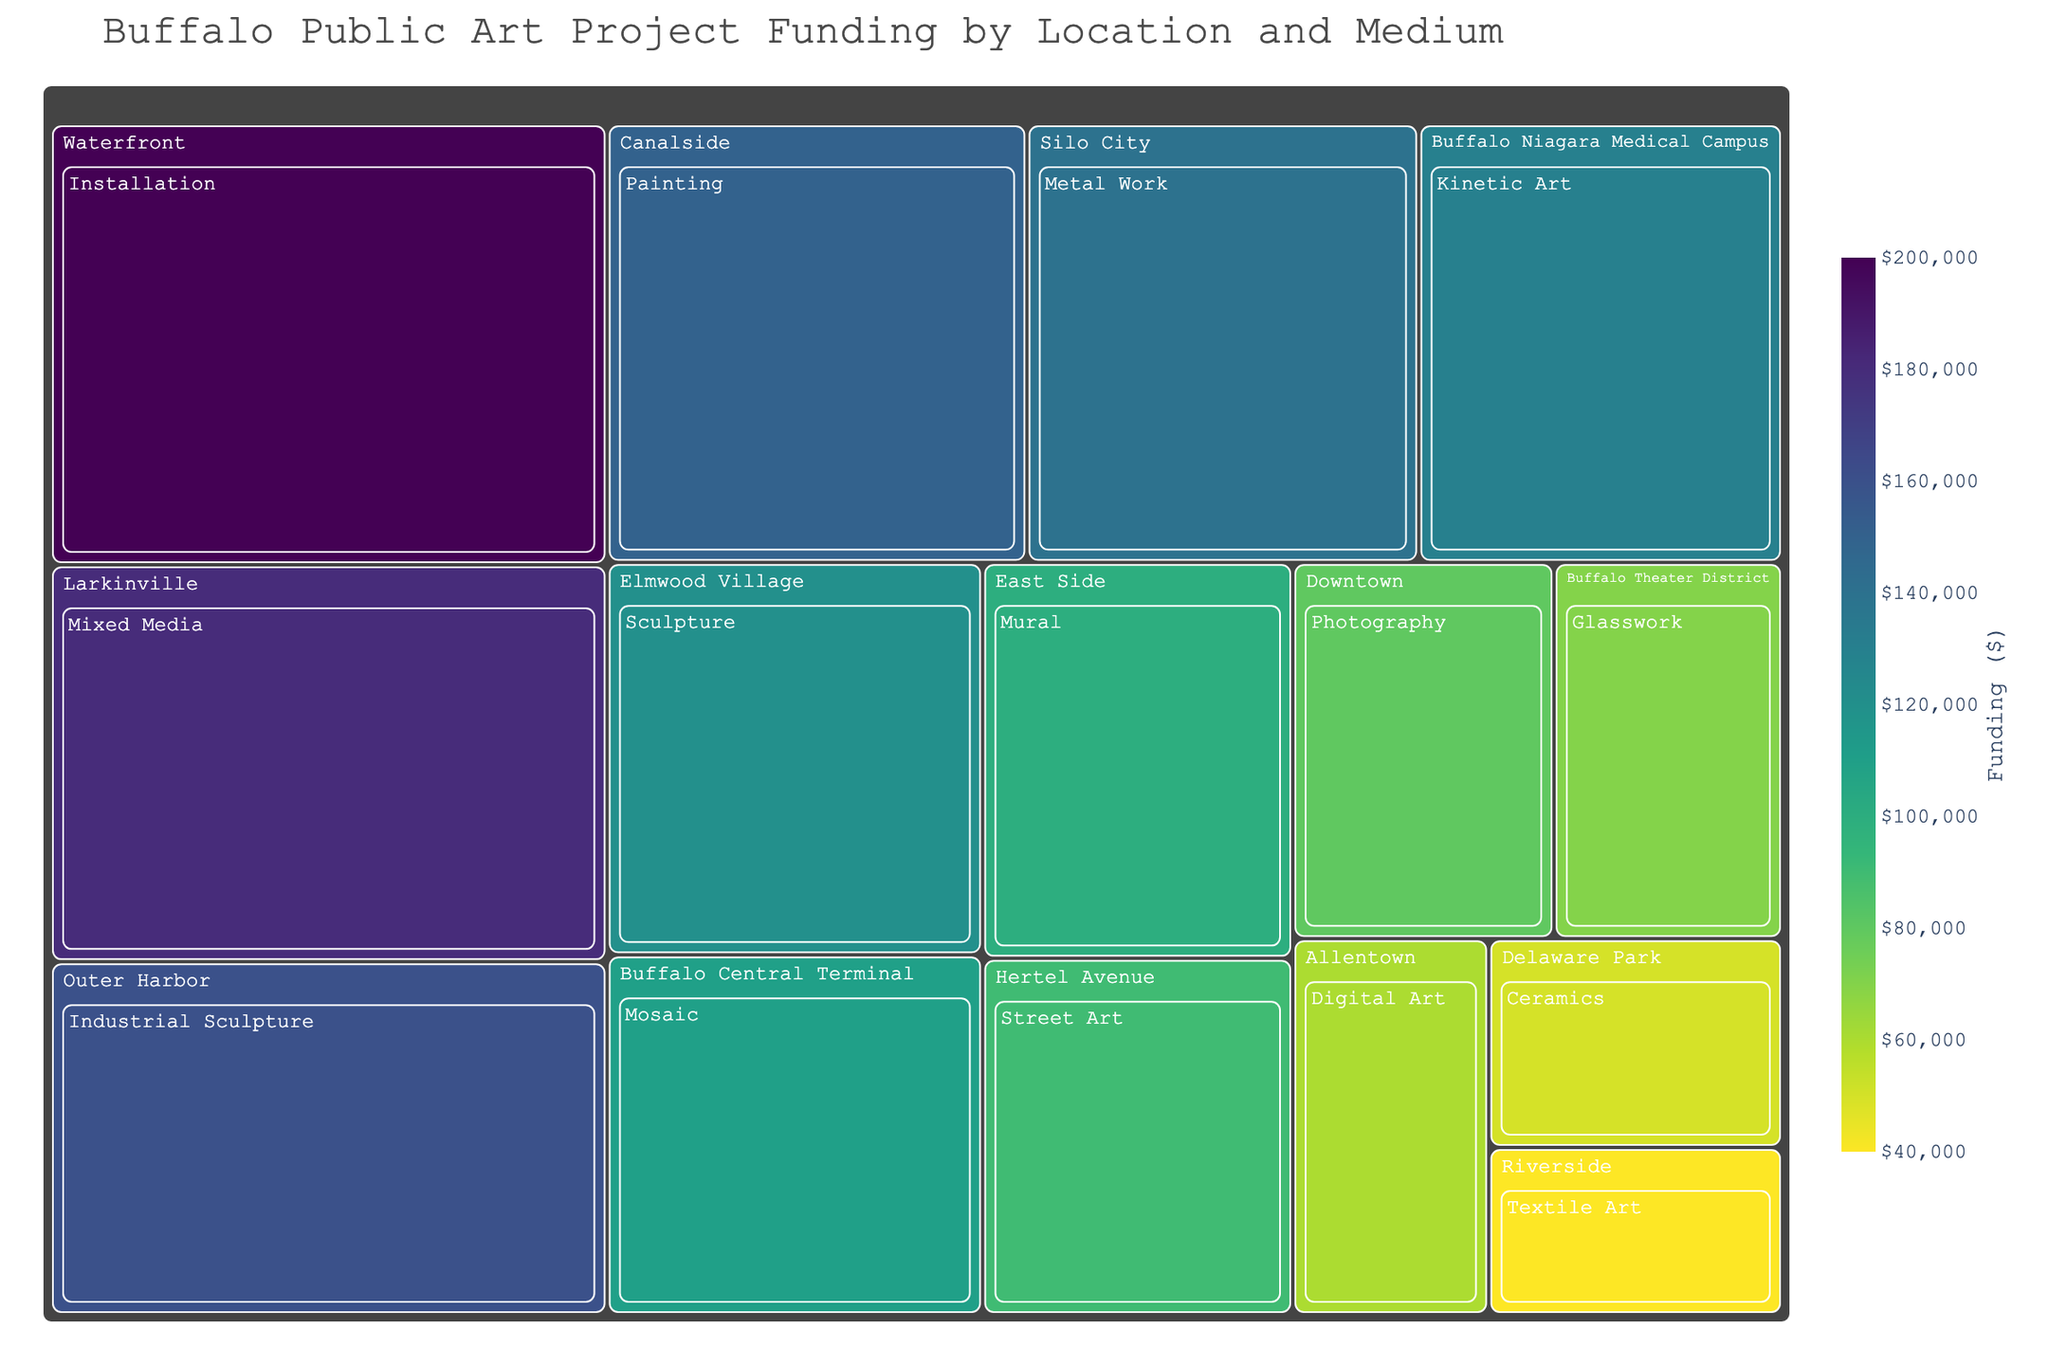What's the title of the figure? The title text is usually in a larger font and often positioned at the top of the figure. One can directly read the title from there.
Answer: Buffalo Public Art Project Funding by Location and Medium Which medium received the most funding? In a treemap, larger rectangles represent higher values. The medium with the largest rectangle has the highest funding.
Answer: Installation What was the total funding for projects in Larkinville? Locate the Larkinville section and add up the funding amounts listed for each medium in that location. Here, there's only one medium.
Answer: $180,000 Compare the funding for Painting in Canalside to Mixed Media in Larkinville. Which one received more funding? Find the size and funding amount for Painting in Canalside and Mixed Media in Larkinville, then compare the two values.
Answer: Mixed Media in Larkinville Which location received the least amount of funding and which medium was it for? Find the smallest rectangle in the treemap, which indicates the lowest funding. Check the label for location and medium.
Answer: Textile Art in Riverside How much more funding did Sculpture in Elmwood Village receive compared to Ceramics in Delaware Park? Identify the funding values for Sculpture in Elmwood Village and Ceramics in Delaware Park, and calculate the difference. Sculpture received $120,000, Ceramics received $50,000. The difference is $120,000 - $50,000.
Answer: $70,000 What's the average funding amount for all projects in Buffalo? Sum up all the funding amounts for each medium and location, then divide by the number of data points. Sum is $1,400,000; number of data points is 15. $1,400,000 / 15 = $93,333.33.
Answer: $93,333.33 Which medium has a funding exactly two times more than Photography in Downtown? Find the funding for Photography in Downtown ($80,000) and identify which medium has twice this funding. $80,000 * 2 = $160,000. The matching medium is Industrial Sculpture in Outer Harbor.
Answer: Industrial Sculpture in Outer Harbor What percentage of the total funding does the project in Waterfront contribute? Find the funding amount for the Waterfront ($200,000), and calculate what percentage this is of the total funding. Total funding is $1,400,000. ($200,000 / $1,400,000) * 100 = 14.29%.
Answer: 14.29% Which mediums received funding in locations associated with Buffalo's industrial heritage? Identify locations related to Buffalo’s industrial heritage (e.g., Silo City and Outer Harbor) and list the mediums and their funding amounts in those locations.
Answer: Metal Work, Industrial Sculpture 